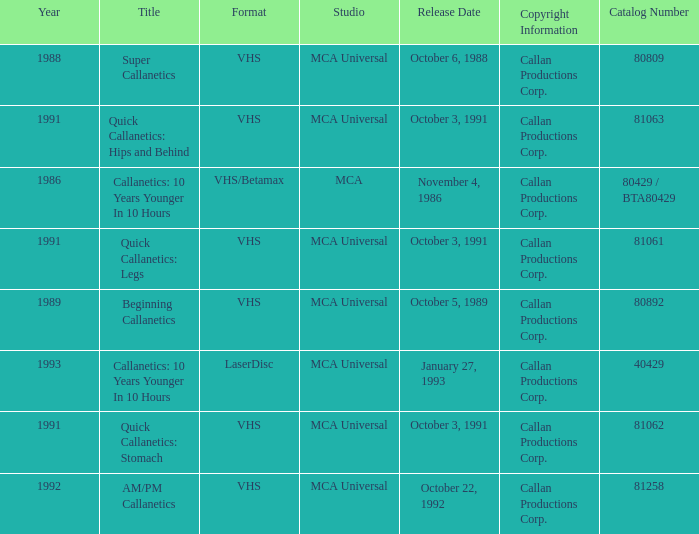Name the format for  quick callanetics: hips and behind VHS. 